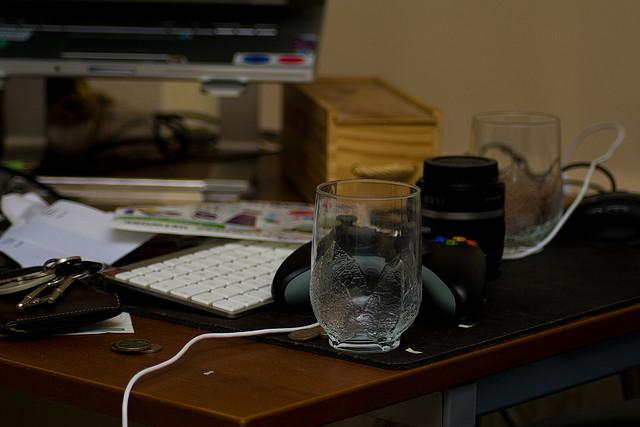What are most keys made of? Please explain your reasoning. steel/brass/iron. The keys are made of steel. 